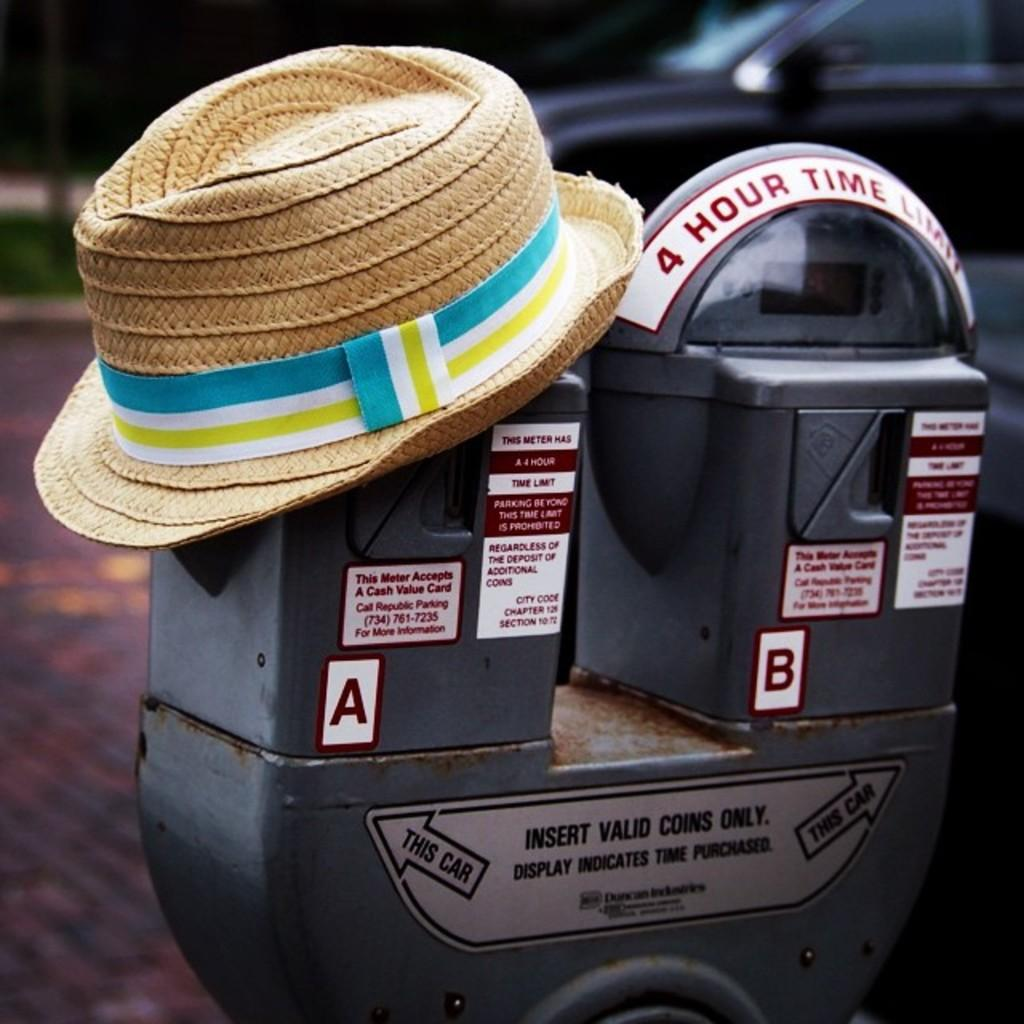Provide a one-sentence caption for the provided image. A parking meter with a 4 hour parking time limit. 